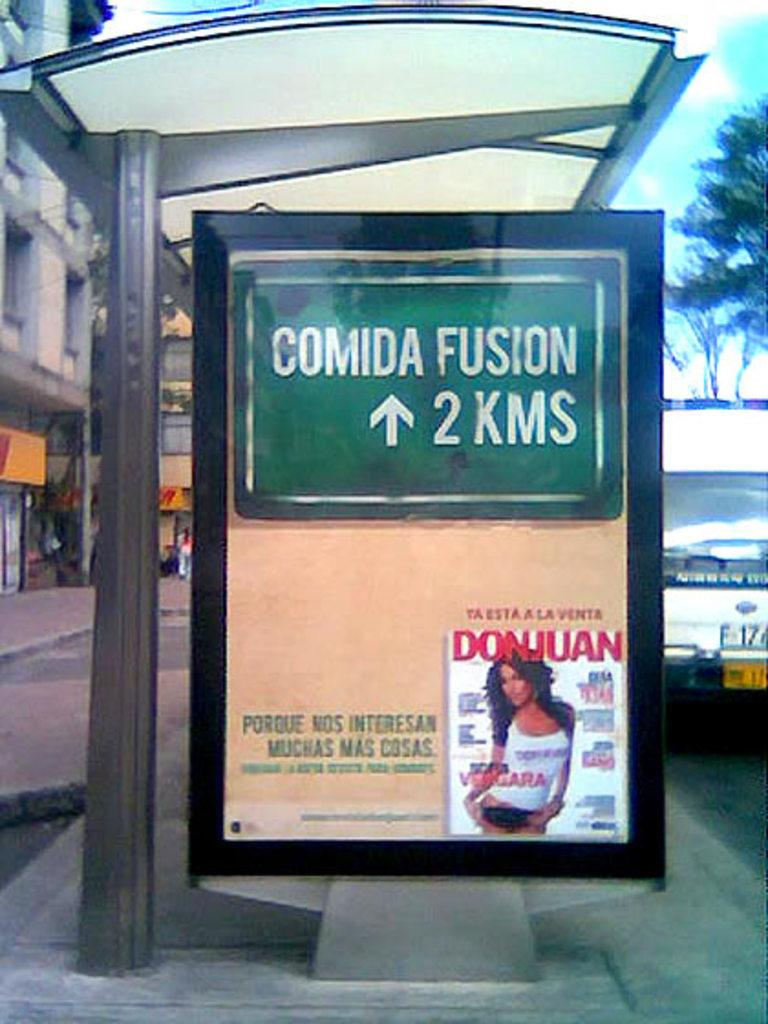<image>
Provide a brief description of the given image. Bus stop with an ad for the magazine Donjuan. 